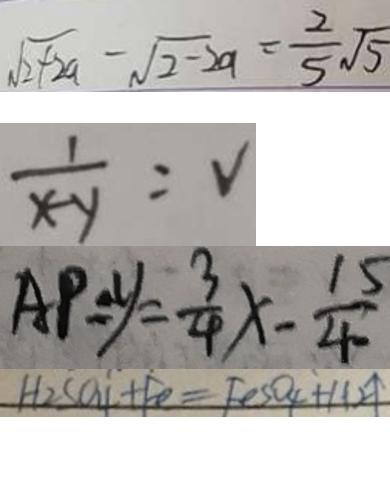<formula> <loc_0><loc_0><loc_500><loc_500>\sqrt { 2 + 2 a } - \sqrt { 2 } - 2 a = \frac { 2 } { 5 } \sqrt { 5 } 
 \frac { 1 } { x - y } = V 
 A P = y = \frac { 3 } { 4 } x - \frac { 1 5 } { 4 0 } 
 H _ { 2 } S O _ { 4 } + F e = F e S O _ { 4 } + H 2 \uparrow</formula> 